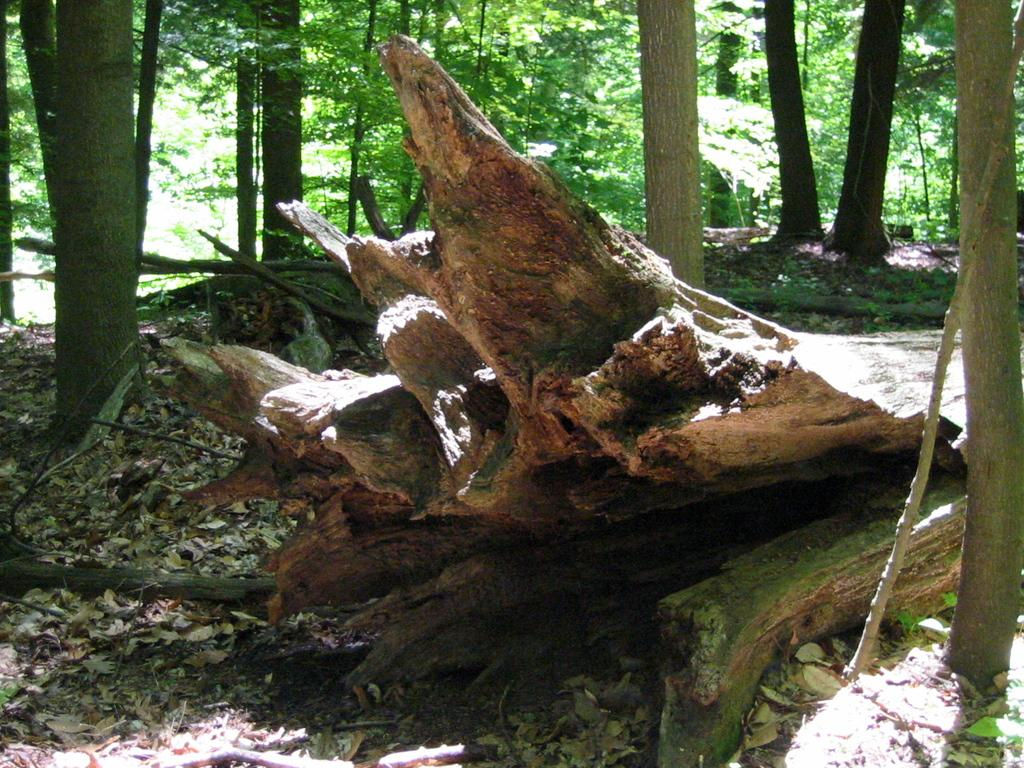What type of material is the main subject of the image made of? The main subject of the image is made of wooden logs. What can be seen on the ground in the image? Dried leaves are present on the ground in the image. What is visible in the background of the image? There are trees visible in the background of the image. What company is responsible for the crib in the image? There is no crib present in the image, so it is not possible to determine which company might be responsible for it. 